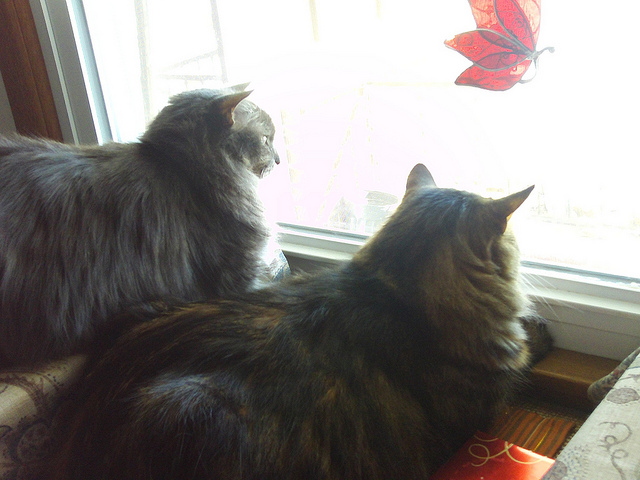<image>What species of cats is looking outside the window? It is ambiguous what species of cat is looking outside the window. It could be a main coon, a cheshire or a domestic house cat. What species of cats is looking outside the window? I'm not sure what species of cats is looking outside the window. It could be Main Coon, long-haired cat, Cheshire or domestic house cat. 